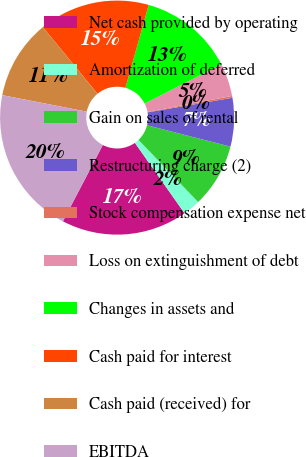Convert chart to OTSL. <chart><loc_0><loc_0><loc_500><loc_500><pie_chart><fcel>Net cash provided by operating<fcel>Amortization of deferred<fcel>Gain on sales of rental<fcel>Restructuring charge (2)<fcel>Stock compensation expense net<fcel>Loss on extinguishment of debt<fcel>Changes in assets and<fcel>Cash paid for interest<fcel>Cash paid (received) for<fcel>EBITDA<nl><fcel>17.44%<fcel>2.4%<fcel>8.84%<fcel>6.7%<fcel>0.25%<fcel>4.55%<fcel>13.14%<fcel>15.29%<fcel>10.99%<fcel>20.41%<nl></chart> 